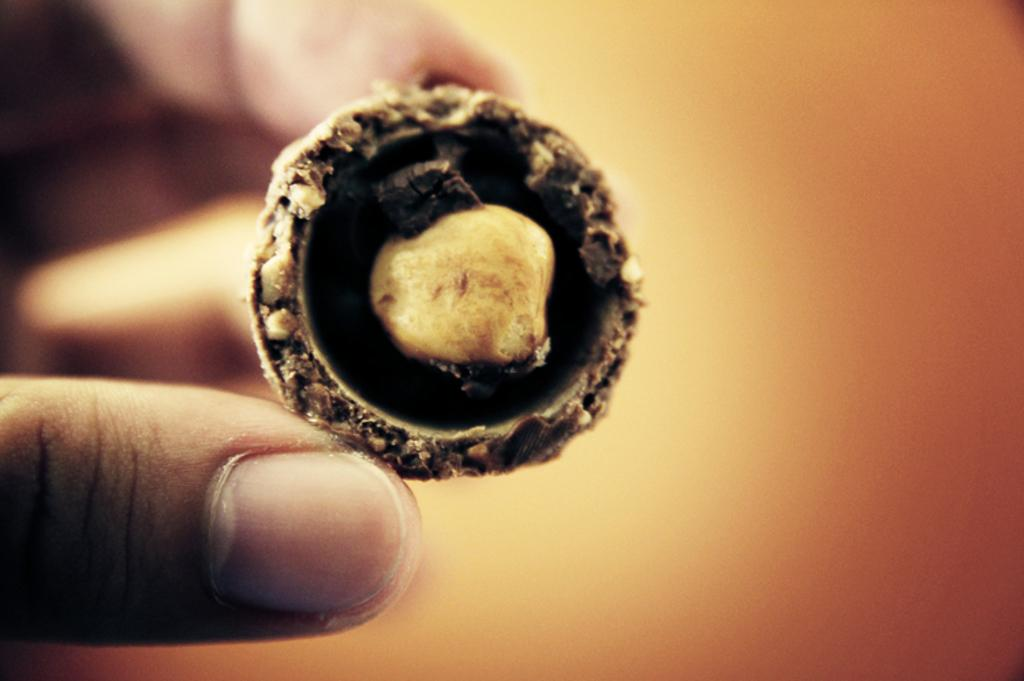What is the person in the image holding? The person is holding an object in the image. Can you describe the person's hand in the image? The fingers of the person are visible on the left side of the image. What colors can be seen on the right side of the image? There is orange and yellow color on the right side of the image. What verse is the person reciting in the image? There is no indication in the image that the person is reciting a verse. 